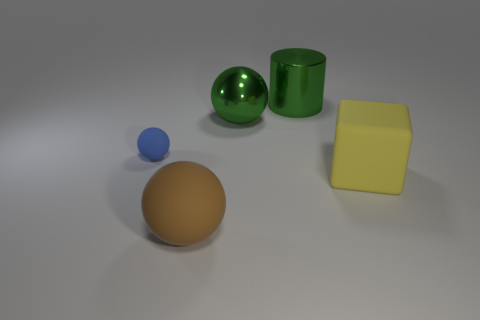What is the shape of the large thing that is the same color as the large metallic ball?
Your answer should be compact. Cylinder. The ball that is the same color as the large shiny cylinder is what size?
Your answer should be compact. Large. There is a large brown matte object; what number of big green shiny balls are to the right of it?
Your response must be concise. 1. What is the size of the green thing right of the green thing that is in front of the green shiny cylinder?
Keep it short and to the point. Large. Does the green metal thing in front of the metal cylinder have the same shape as the rubber thing in front of the big yellow thing?
Offer a terse response. Yes. There is a large rubber thing that is on the left side of the big shiny object that is in front of the big cylinder; what shape is it?
Your answer should be very brief. Sphere. There is a rubber thing that is both behind the big matte ball and on the right side of the tiny blue object; what is its size?
Provide a succinct answer. Large. There is a small matte object; is its shape the same as the object that is in front of the yellow object?
Provide a short and direct response. Yes. What size is the green object that is the same shape as the tiny blue matte thing?
Provide a succinct answer. Large. Do the metal cylinder and the big rubber object that is in front of the yellow matte object have the same color?
Your answer should be very brief. No. 